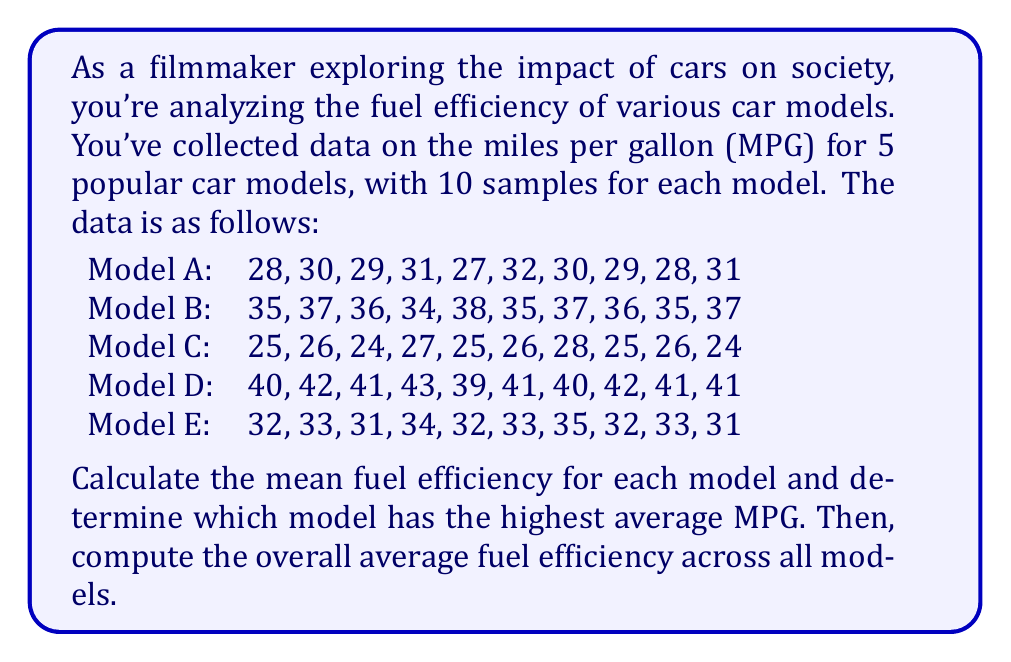Could you help me with this problem? To solve this problem, we'll follow these steps:

1. Calculate the mean fuel efficiency for each model
2. Determine which model has the highest average MPG
3. Compute the overall average fuel efficiency across all models

Step 1: Calculate the mean fuel efficiency for each model

We'll use the formula for arithmetic mean:

$$ \text{Mean} = \frac{\sum_{i=1}^{n} x_i}{n} $$

Where $x_i$ represents each data point and $n$ is the number of data points.

Model A:
$$ \text{Mean}_A = \frac{28 + 30 + 29 + 31 + 27 + 32 + 30 + 29 + 28 + 31}{10} = \frac{295}{10} = 29.5 \text{ MPG} $$

Model B:
$$ \text{Mean}_B = \frac{35 + 37 + 36 + 34 + 38 + 35 + 37 + 36 + 35 + 37}{10} = \frac{360}{10} = 36 \text{ MPG} $$

Model C:
$$ \text{Mean}_C = \frac{25 + 26 + 24 + 27 + 25 + 26 + 28 + 25 + 26 + 24}{10} = \frac{256}{10} = 25.6 \text{ MPG} $$

Model D:
$$ \text{Mean}_D = \frac{40 + 42 + 41 + 43 + 39 + 41 + 40 + 42 + 41 + 41}{10} = \frac{410}{10} = 41 \text{ MPG} $$

Model E:
$$ \text{Mean}_E = \frac{32 + 33 + 31 + 34 + 32 + 33 + 35 + 32 + 33 + 31}{10} = \frac{326}{10} = 32.6 \text{ MPG} $$

Step 2: Determine which model has the highest average MPG

Comparing the means:
Model A: 29.5 MPG
Model B: 36.0 MPG
Model C: 25.6 MPG
Model D: 41.0 MPG
Model E: 32.6 MPG

Model D has the highest average MPG at 41.0 MPG.

Step 3: Compute the overall average fuel efficiency across all models

To find the overall average, we'll calculate the mean of the means:

$$ \text{Overall Mean} = \frac{29.5 + 36.0 + 25.6 + 41.0 + 32.6}{5} = \frac{164.7}{5} = 32.94 \text{ MPG} $$
Answer: Model D has the highest average fuel efficiency at 41.0 MPG. The overall average fuel efficiency across all models is 32.94 MPG. 